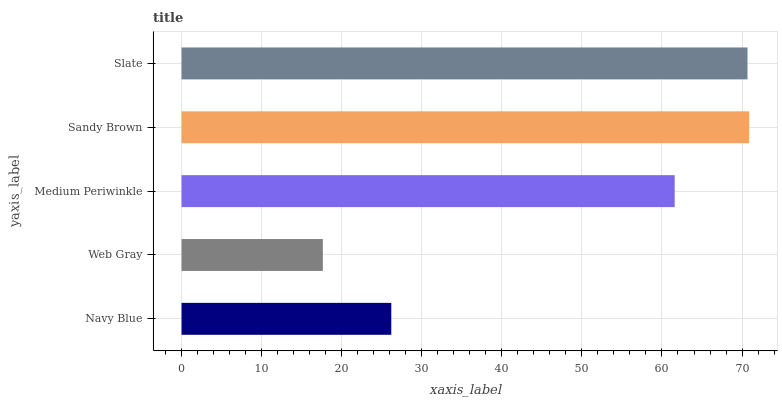Is Web Gray the minimum?
Answer yes or no. Yes. Is Sandy Brown the maximum?
Answer yes or no. Yes. Is Medium Periwinkle the minimum?
Answer yes or no. No. Is Medium Periwinkle the maximum?
Answer yes or no. No. Is Medium Periwinkle greater than Web Gray?
Answer yes or no. Yes. Is Web Gray less than Medium Periwinkle?
Answer yes or no. Yes. Is Web Gray greater than Medium Periwinkle?
Answer yes or no. No. Is Medium Periwinkle less than Web Gray?
Answer yes or no. No. Is Medium Periwinkle the high median?
Answer yes or no. Yes. Is Medium Periwinkle the low median?
Answer yes or no. Yes. Is Slate the high median?
Answer yes or no. No. Is Slate the low median?
Answer yes or no. No. 